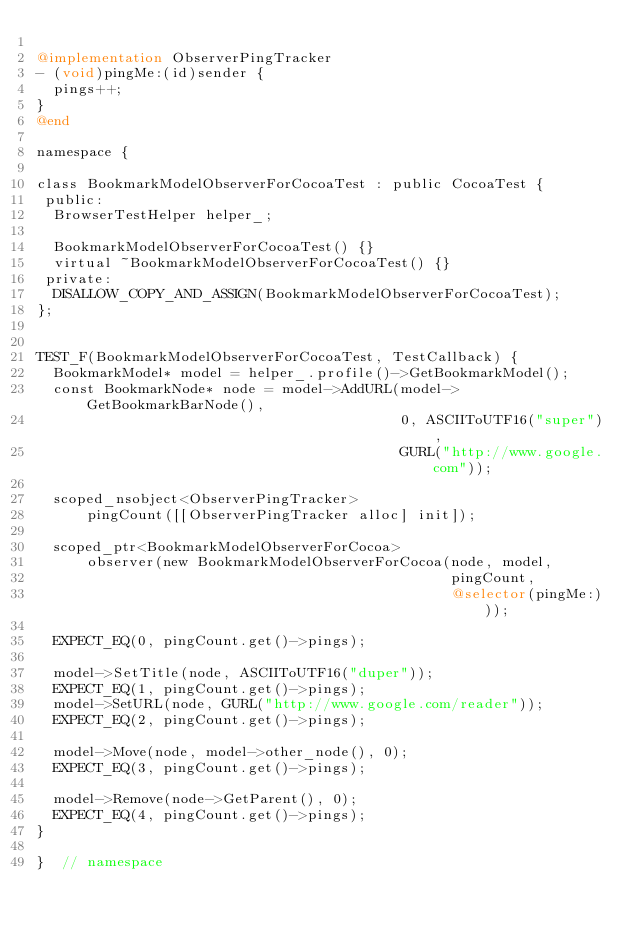Convert code to text. <code><loc_0><loc_0><loc_500><loc_500><_ObjectiveC_>
@implementation ObserverPingTracker
- (void)pingMe:(id)sender {
  pings++;
}
@end

namespace {

class BookmarkModelObserverForCocoaTest : public CocoaTest {
 public:
  BrowserTestHelper helper_;

  BookmarkModelObserverForCocoaTest() {}
  virtual ~BookmarkModelObserverForCocoaTest() {}
 private:
  DISALLOW_COPY_AND_ASSIGN(BookmarkModelObserverForCocoaTest);
};


TEST_F(BookmarkModelObserverForCocoaTest, TestCallback) {
  BookmarkModel* model = helper_.profile()->GetBookmarkModel();
  const BookmarkNode* node = model->AddURL(model->GetBookmarkBarNode(),
                                           0, ASCIIToUTF16("super"),
                                           GURL("http://www.google.com"));

  scoped_nsobject<ObserverPingTracker>
      pingCount([[ObserverPingTracker alloc] init]);

  scoped_ptr<BookmarkModelObserverForCocoa>
      observer(new BookmarkModelObserverForCocoa(node, model,
                                                 pingCount,
                                                 @selector(pingMe:)));

  EXPECT_EQ(0, pingCount.get()->pings);

  model->SetTitle(node, ASCIIToUTF16("duper"));
  EXPECT_EQ(1, pingCount.get()->pings);
  model->SetURL(node, GURL("http://www.google.com/reader"));
  EXPECT_EQ(2, pingCount.get()->pings);

  model->Move(node, model->other_node(), 0);
  EXPECT_EQ(3, pingCount.get()->pings);

  model->Remove(node->GetParent(), 0);
  EXPECT_EQ(4, pingCount.get()->pings);
}

}  // namespace
</code> 